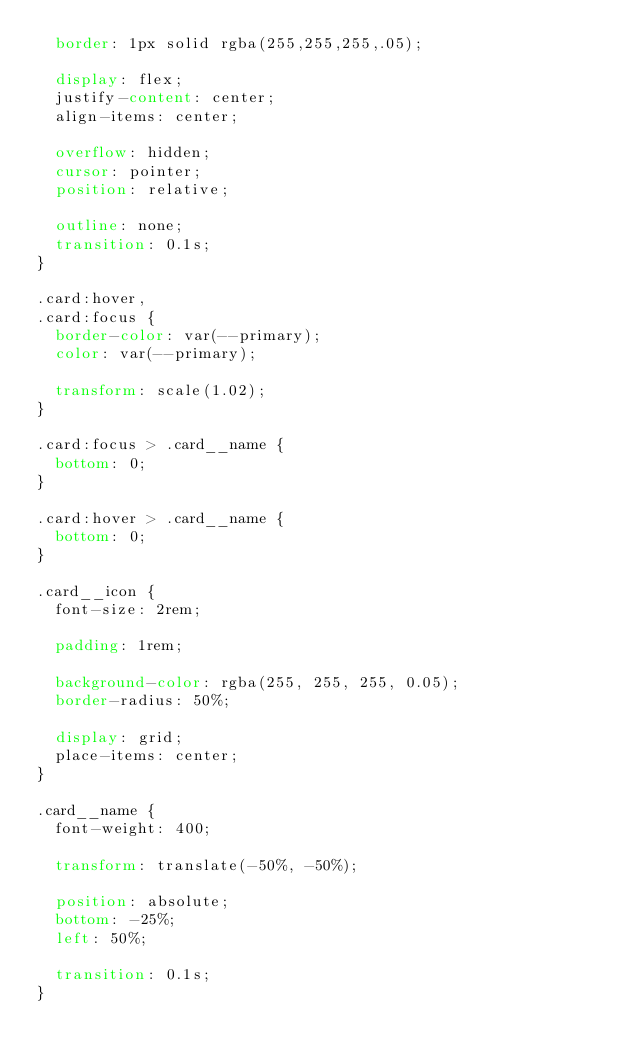Convert code to text. <code><loc_0><loc_0><loc_500><loc_500><_CSS_>  border: 1px solid rgba(255,255,255,.05);

  display: flex;
  justify-content: center;
  align-items: center;

  overflow: hidden;
  cursor: pointer;
  position: relative;

  outline: none;
  transition: 0.1s;
}

.card:hover,
.card:focus {
  border-color: var(--primary);
  color: var(--primary);

  transform: scale(1.02);
}

.card:focus > .card__name {
  bottom: 0;
}

.card:hover > .card__name {
  bottom: 0;
}

.card__icon {
  font-size: 2rem;

  padding: 1rem;

  background-color: rgba(255, 255, 255, 0.05);
  border-radius: 50%;

  display: grid;
  place-items: center;
}

.card__name {
  font-weight: 400;

  transform: translate(-50%, -50%);

  position: absolute;
  bottom: -25%;
  left: 50%;

  transition: 0.1s;
}
</code> 